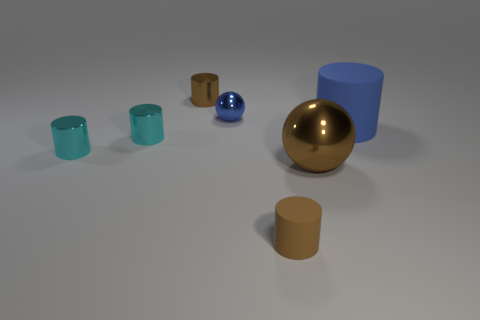Subtract 1 cylinders. How many cylinders are left? 4 Subtract all large blue cylinders. How many cylinders are left? 4 Subtract all brown cylinders. How many cylinders are left? 3 Subtract all red cylinders. Subtract all blue blocks. How many cylinders are left? 5 Add 1 small blue rubber blocks. How many objects exist? 8 Subtract all cylinders. How many objects are left? 2 Subtract 0 yellow cylinders. How many objects are left? 7 Subtract all small cyan spheres. Subtract all big rubber things. How many objects are left? 6 Add 3 tiny rubber cylinders. How many tiny rubber cylinders are left? 4 Add 2 spheres. How many spheres exist? 4 